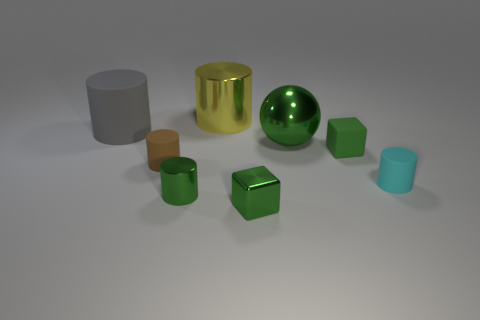There is a tiny cube to the right of the small shiny object to the right of the shiny cylinder that is in front of the big gray rubber cylinder; what is its color?
Ensure brevity in your answer.  Green. Is there any other thing that is the same material as the small cyan thing?
Make the answer very short. Yes. Does the tiny green object on the right side of the big green shiny thing have the same shape as the yellow shiny object?
Provide a short and direct response. No. What is the material of the green cylinder?
Your answer should be compact. Metal. What shape is the green metallic thing that is behind the green block behind the small green block in front of the cyan cylinder?
Make the answer very short. Sphere. What number of other objects are there of the same shape as the gray object?
Provide a succinct answer. 4. Does the tiny matte block have the same color as the metal cylinder in front of the big ball?
Keep it short and to the point. Yes. How many tiny cylinders are there?
Offer a very short reply. 3. How many things are either big gray rubber cylinders or blue matte things?
Your response must be concise. 1. What size is the ball that is the same color as the metal cube?
Provide a short and direct response. Large. 